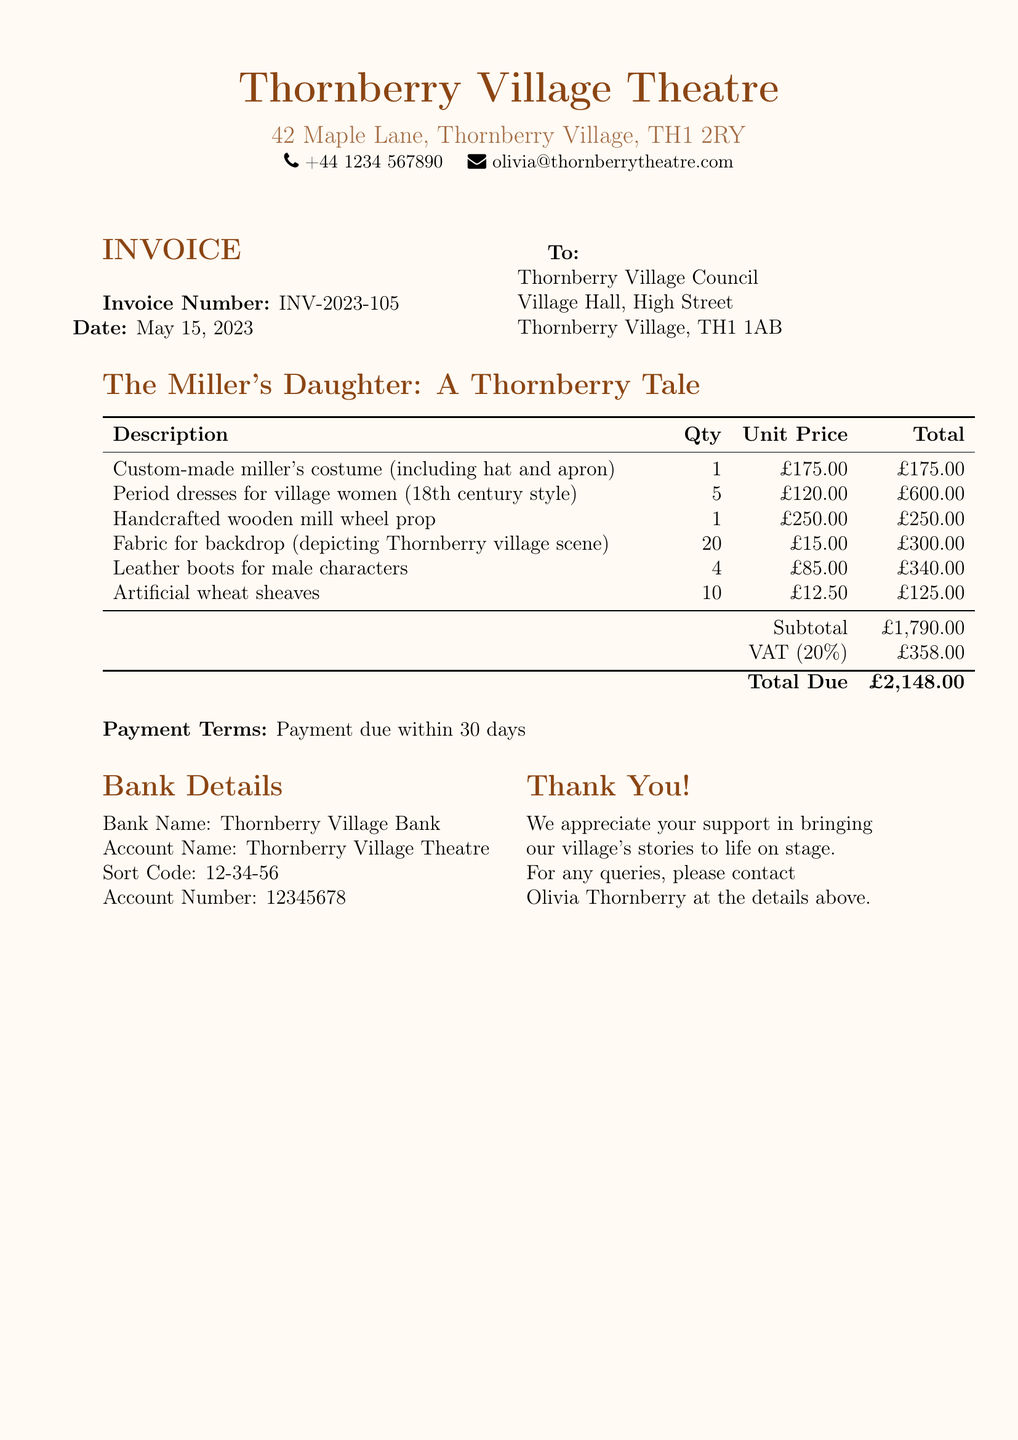What is the invoice number? The invoice number is specified in the document as a unique identifier for the transaction.
Answer: INV-2023-105 What is the subtotal amount? The subtotal is the total before VAT is applied, which is provided in the invoice details.
Answer: £1,790.00 What is the total due? The total due is the final amount payable including VAT, calculated from the subtotal.
Answer: £2,148.00 How many period dresses are ordered? The document lists the quantity of period dresses ordered as outlined in the itemized section.
Answer: 5 Who should be contacted for queries? The contact person for queries is mentioned at the end of the invoice in the 'Thank You!' section.
Answer: Olivia Thornberry What is the VAT percentage? The VAT percentage is explicitly stated in the invoice breakdown section.
Answer: 20% What type of costume is included? The description specifies the type of costume as part of the detailed items provided in the invoice.
Answer: Custom-made miller's costume What is the account number for payments? The document provides specific bank details, including the account number for transactions.
Answer: 12345678 What is the payment term? The payment term is clearly stated in the invoice, indicating when payment should be made.
Answer: Payment due within 30 days 